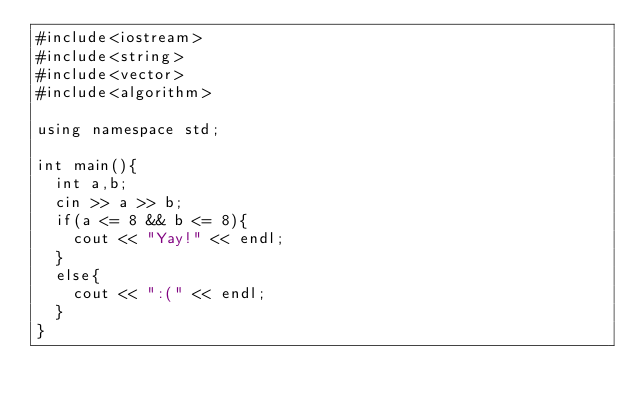Convert code to text. <code><loc_0><loc_0><loc_500><loc_500><_C++_>#include<iostream>
#include<string>
#include<vector>
#include<algorithm>

using namespace std;

int main(){
  int a,b;
  cin >> a >> b;
  if(a <= 8 && b <= 8){
    cout << "Yay!" << endl;
  }
  else{
    cout << ":(" << endl;
  }
}
</code> 